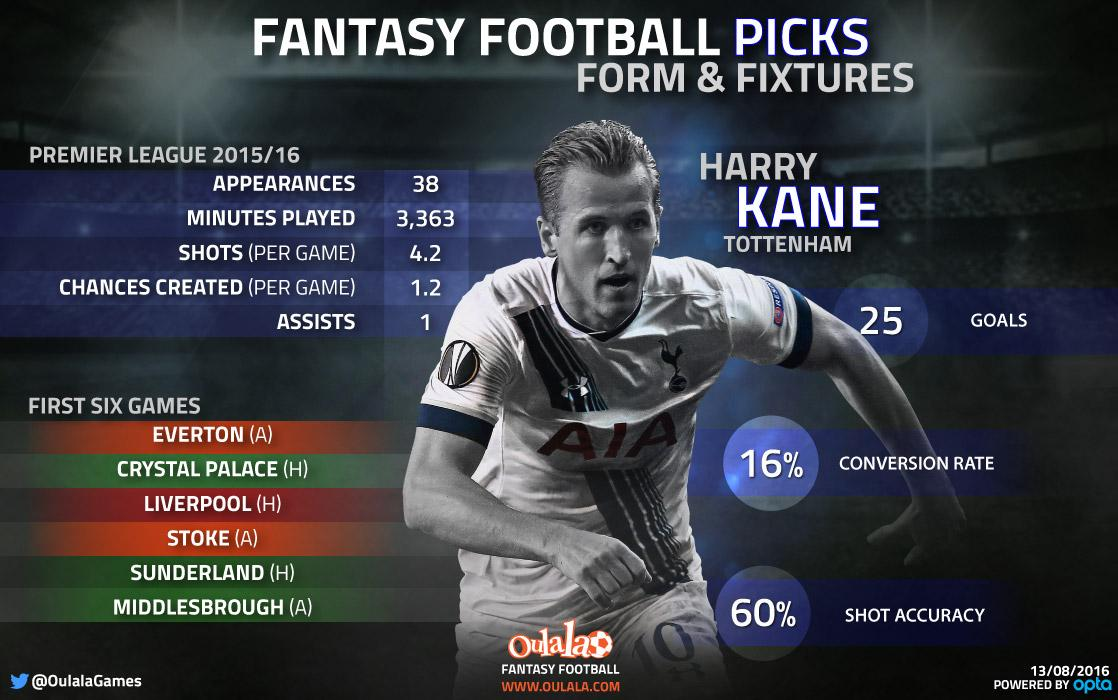Indicate a few pertinent items in this graphic. The text on the jersey t-shirt of the player reads "AIA. The image depicts a player named Harry Kane, who is affiliated with Tottenham. The player's middle name is Kane. The number written on the shorts of the player is 10. The player's jersey is white. 